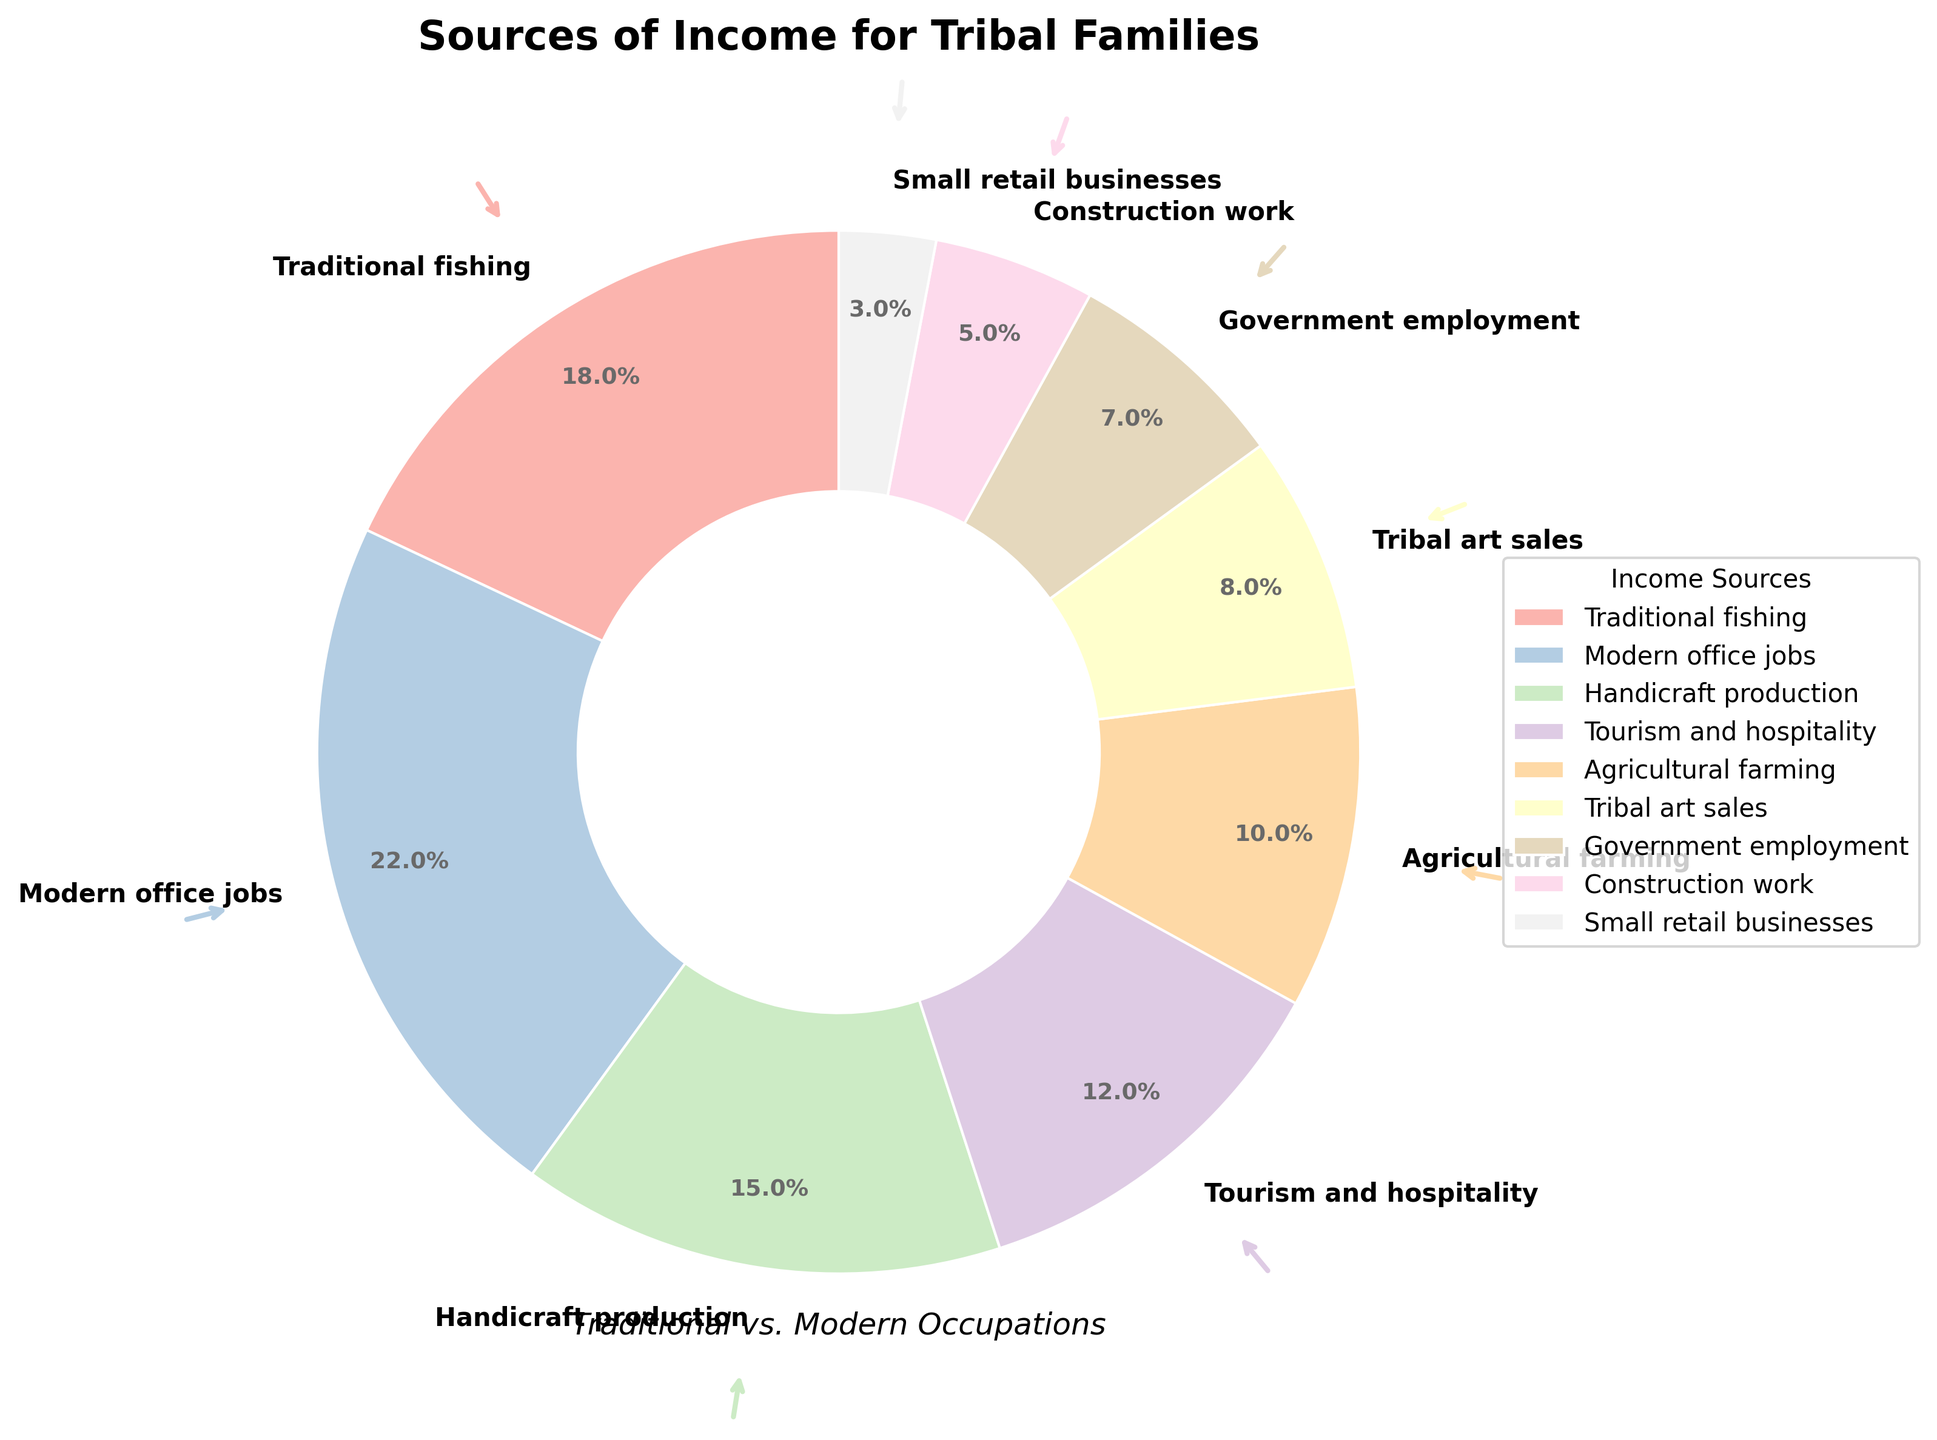Which source provides the highest percentage of income? The highest percentage in the pie chart is associated with modern office jobs, which account for 22% of the total income.
Answer: Modern office jobs What is the combined percentage of income from traditional fishing and tribal art sales? Adding the percentages from traditional fishing (18%) and tribal art sales (8%) gives 18% + 8% = 26%.
Answer: 26% Which source provides a smaller percentage of income: small retail businesses or construction work? By comparing the percentages, small retail businesses provide 3% and construction work provides 5%. Since 3% is less than 5%, small retail businesses provide a smaller percentage of income.
Answer: Small retail businesses What is the visual significance of the largest wedge in the pie chart? The largest wedge represents modern office jobs, indicating that it contributes the most, 22%, to the income sources for tribal families. This wedge is visually the largest, highlighting its importance.
Answer: Modern office jobs How does the percentage of income from handicraft production compare to that from tourism and hospitality? Handicraft production contributes 15%, while tourism and hospitality contribute 12%. Therefore, handicraft production provides a larger percentage of income.
Answer: Handicraft production What are the total combined percentages of income from all traditional occupations? Traditional occupations include traditional fishing (18%), handicraft production (15%), agricultural farming (10%), and tribal art sales (8%). Summing these percentages: 18% + 15% + 10% + 8% = 51%.
Answer: 51% Which category contributes more towards income: government employment or agricultural farming? Government employment contributes 7%, whereas agricultural farming contributes 10%. Therefore, agricultural farming contributes more towards income.
Answer: Agricultural farming What is the difference in percentage between the highest and lowest sources of income? The highest source is modern office jobs at 22%, and the lowest is small retail businesses at 3%. The difference is calculated as 22% - 3% = 19%.
Answer: 19% If you combine income from construction work and government employment, is it more or less than the income from tourism and hospitality? Construction work contributes 5% and government employment 7%, summing to 5% + 7% = 12%. Tourism and hospitality also contributes 12%. Since both sums are equal, they are the same.
Answer: Same What visual elements are used to highlight the importance of each wedge in the pie chart? The pie chart uses arrows and varying wedge sizes to draw attention to each segment. The colors and sizes of the wedges help to visually distinguish and indicate the significance of each income source.
Answer: Arrows, colors, and sizes 